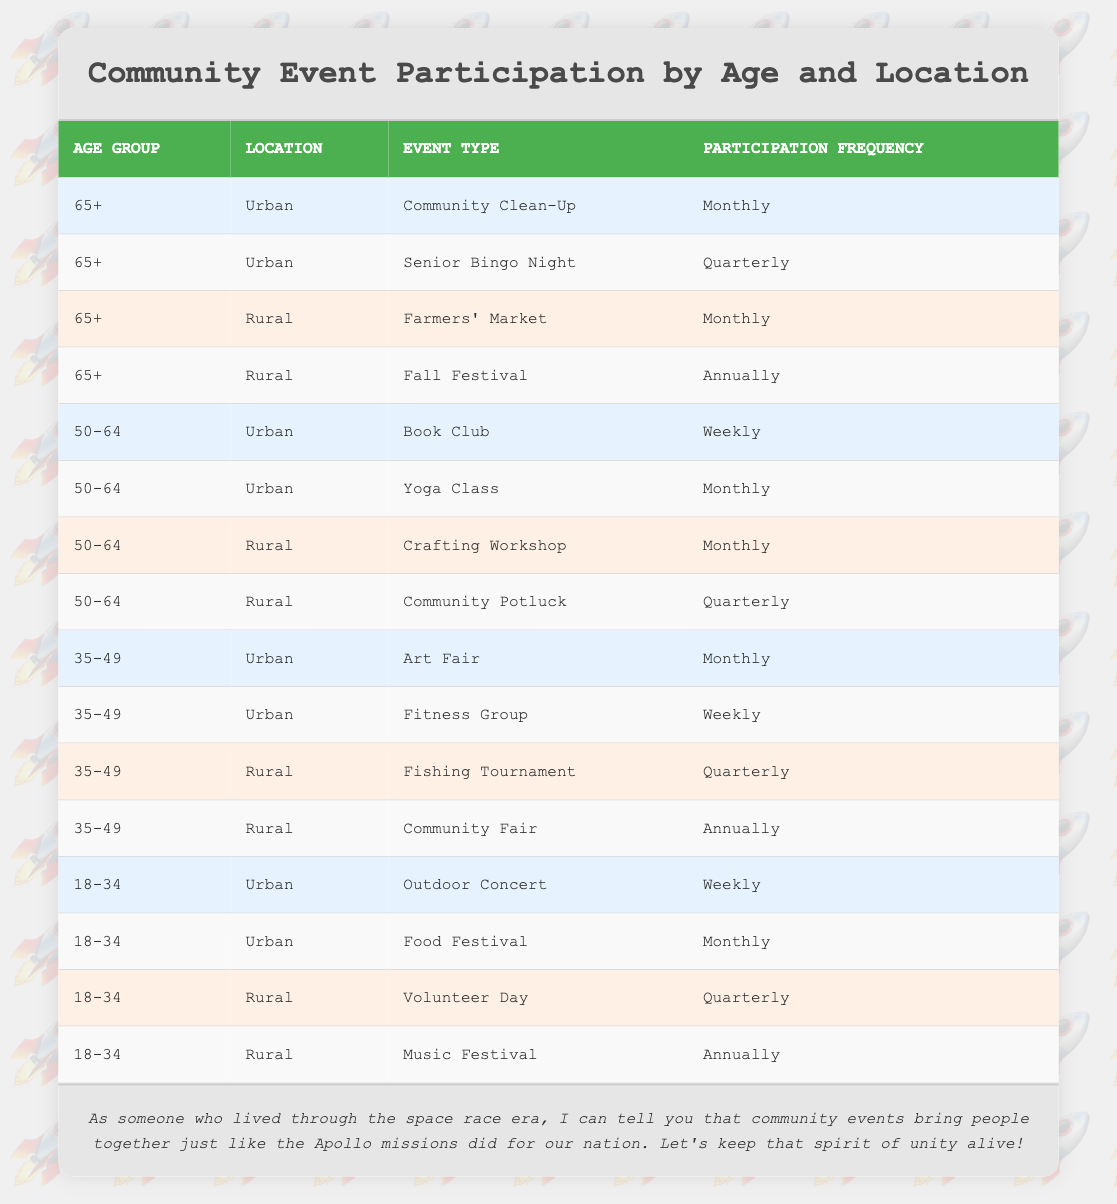What is the participation frequency of the group aged 65+ in Urban for Community Clean-Up? The table specifies the participation frequency for each event. For the event "Community Clean-Up," under the age group "65+" and location "Urban," the frequency is listed as "Monthly."
Answer: Monthly How many types of events do those aged 50-64 participate in Rural? In the Rural location for the age group "50-64," there are two types of events reported: "Crafting Workshop" (Monthly) and "Community Potluck" (Quarterly). These are the only two distinct event types for this age group in the Rural location.
Answer: 2 Are there any events attended by those aged 35-49 in the Rural location that occur Annually? Looking at the events for the age group "35-49" in the Rural location, we see two events: "Fishing Tournament" (Quarterly) and "Community Fair" (Annually). Since "Community Fair" is listed as an Annual event, the answer is true.
Answer: Yes What is the total number of different participation frequencies recorded for the age group 18-34? For age group "18-34," the recorded participation frequencies are: Weekly (Outdoor Concert), Monthly (Food Festival), Quarterly (Volunteer Day), and Annually (Music Festival). There are four unique frequencies in total.
Answer: 4 Which age group has the highest participation frequency for events in Urban? In the Urban area, the age group "50-64" has the highest frequency of participation with "Weekly" for the "Book Club" and "Fitness Group." Thus, this age group may be considered as having the highest participation frequency overall for the unique events listed.
Answer: 50-64 What is the event participation frequency for the Rural location among those aged 18-34? The age group "18-34" in the Rural location participates in "Volunteer Day" (Quarterly) and "Music Festival" (Annually). Hence, there are two distinct events with different frequencies reported here.
Answer: 2 Are participants aged 65+ in the Rural location more likely to attend events monthly compared to those in Urban? In the Rural location, "Farmers' Market" occurs monthly for the age group "65+," whereas in Urban, they participate monthly in "Community Clean-Up." Thus, both locations have one event each with a monthly participation frequency. Therefore, it is not more likely in either location.
Answer: No What is the participation frequency for those aged 35-49 participating in the "Community Fair"? The "Community Fair" is under the age group "35-49" and occurs in Rural, with a listed participation frequency of "Annually."
Answer: Annually 